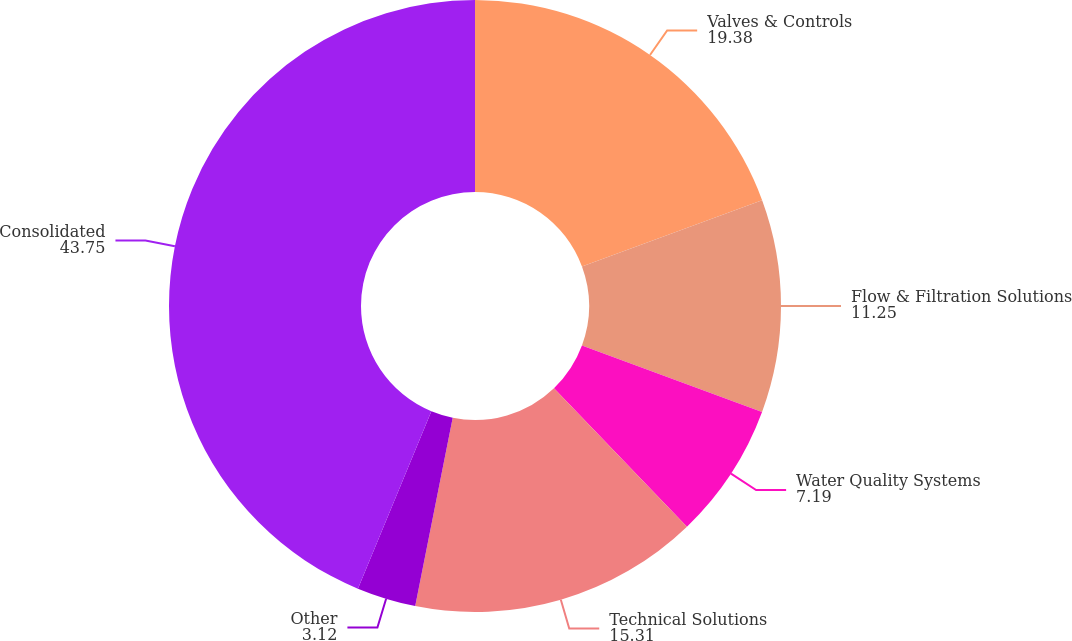Convert chart. <chart><loc_0><loc_0><loc_500><loc_500><pie_chart><fcel>Valves & Controls<fcel>Flow & Filtration Solutions<fcel>Water Quality Systems<fcel>Technical Solutions<fcel>Other<fcel>Consolidated<nl><fcel>19.38%<fcel>11.25%<fcel>7.19%<fcel>15.31%<fcel>3.12%<fcel>43.75%<nl></chart> 